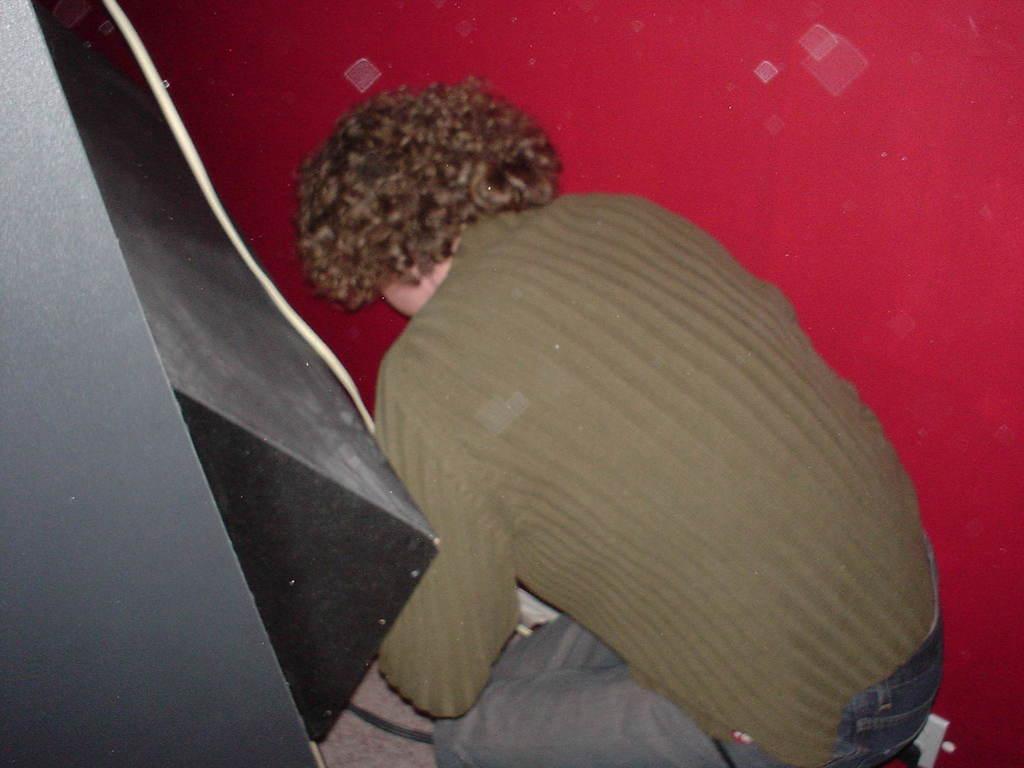Describe this image in one or two sentences. In this picture I can see a person in front who is wearing brown color t-shirt and jeans and on the left side of this picture I can see the black color thing. In the background I can see the red color path. 